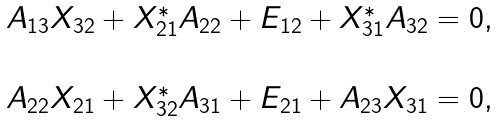<formula> <loc_0><loc_0><loc_500><loc_500>\begin{array} { c } A _ { 1 3 } X _ { 3 2 } + X _ { 2 1 } ^ { * } A _ { 2 2 } + E _ { 1 2 } + X _ { 3 1 } ^ { * } A _ { 3 2 } = 0 , \\ \\ A _ { 2 2 } X _ { 2 1 } + X _ { 3 2 } ^ { * } A _ { 3 1 } + E _ { 2 1 } + A _ { 2 3 } X _ { 3 1 } = 0 , \end{array}</formula> 